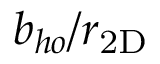<formula> <loc_0><loc_0><loc_500><loc_500>b _ { h o } / r _ { 2 D }</formula> 